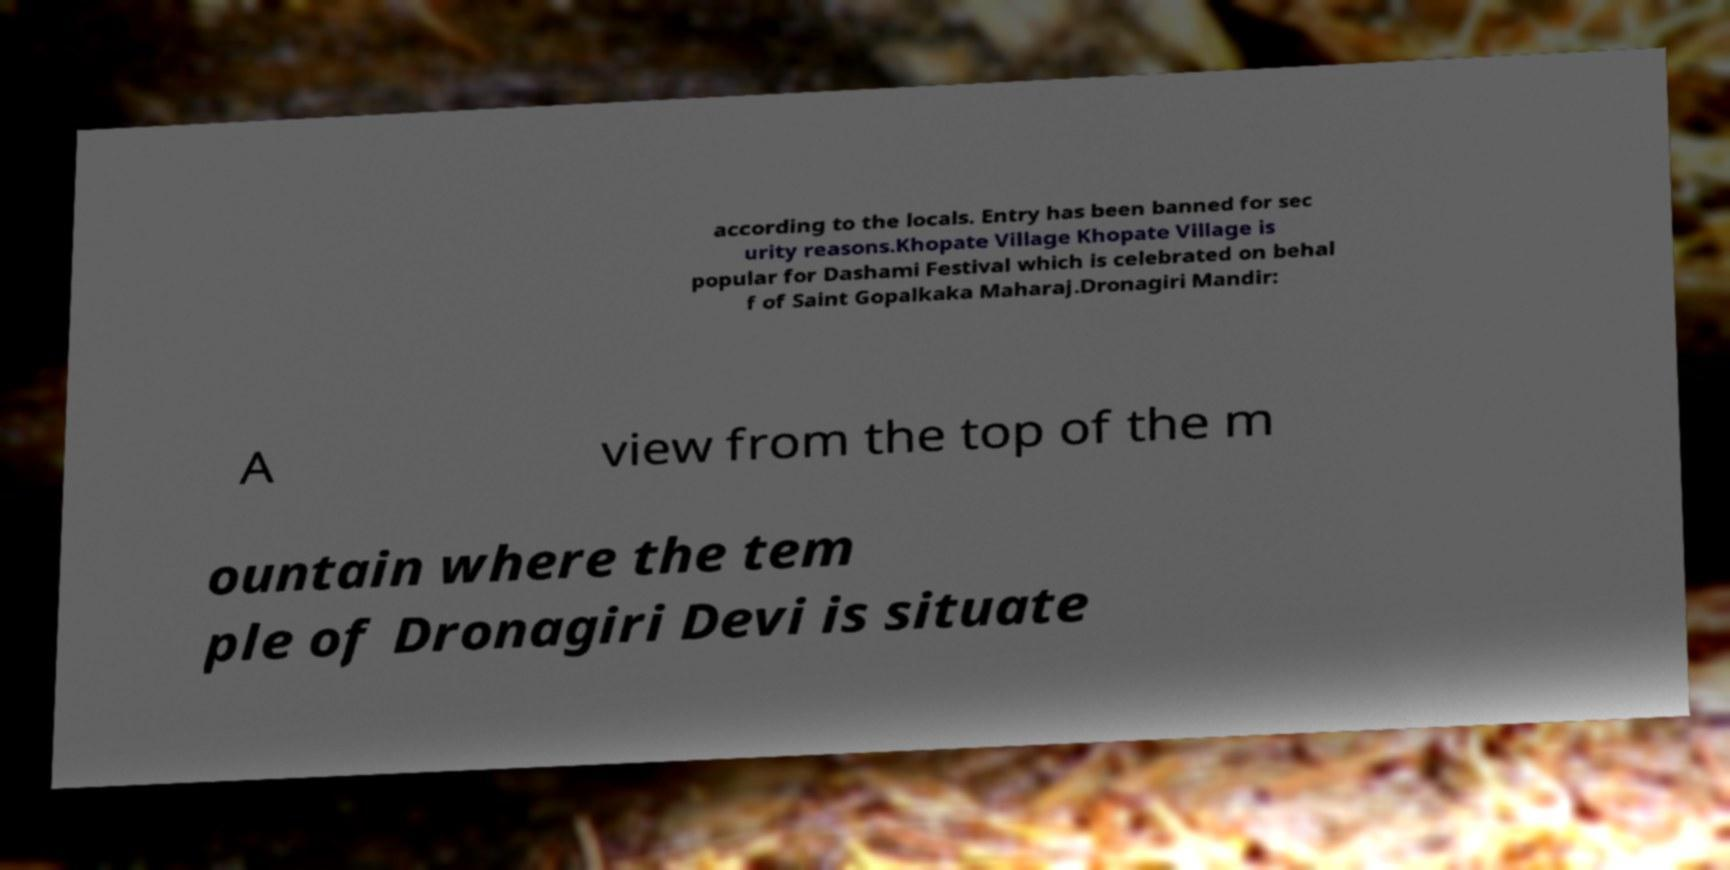For documentation purposes, I need the text within this image transcribed. Could you provide that? according to the locals. Entry has been banned for sec urity reasons.Khopate Village Khopate Village is popular for Dashami Festival which is celebrated on behal f of Saint Gopalkaka Maharaj.Dronagiri Mandir: A view from the top of the m ountain where the tem ple of Dronagiri Devi is situate 